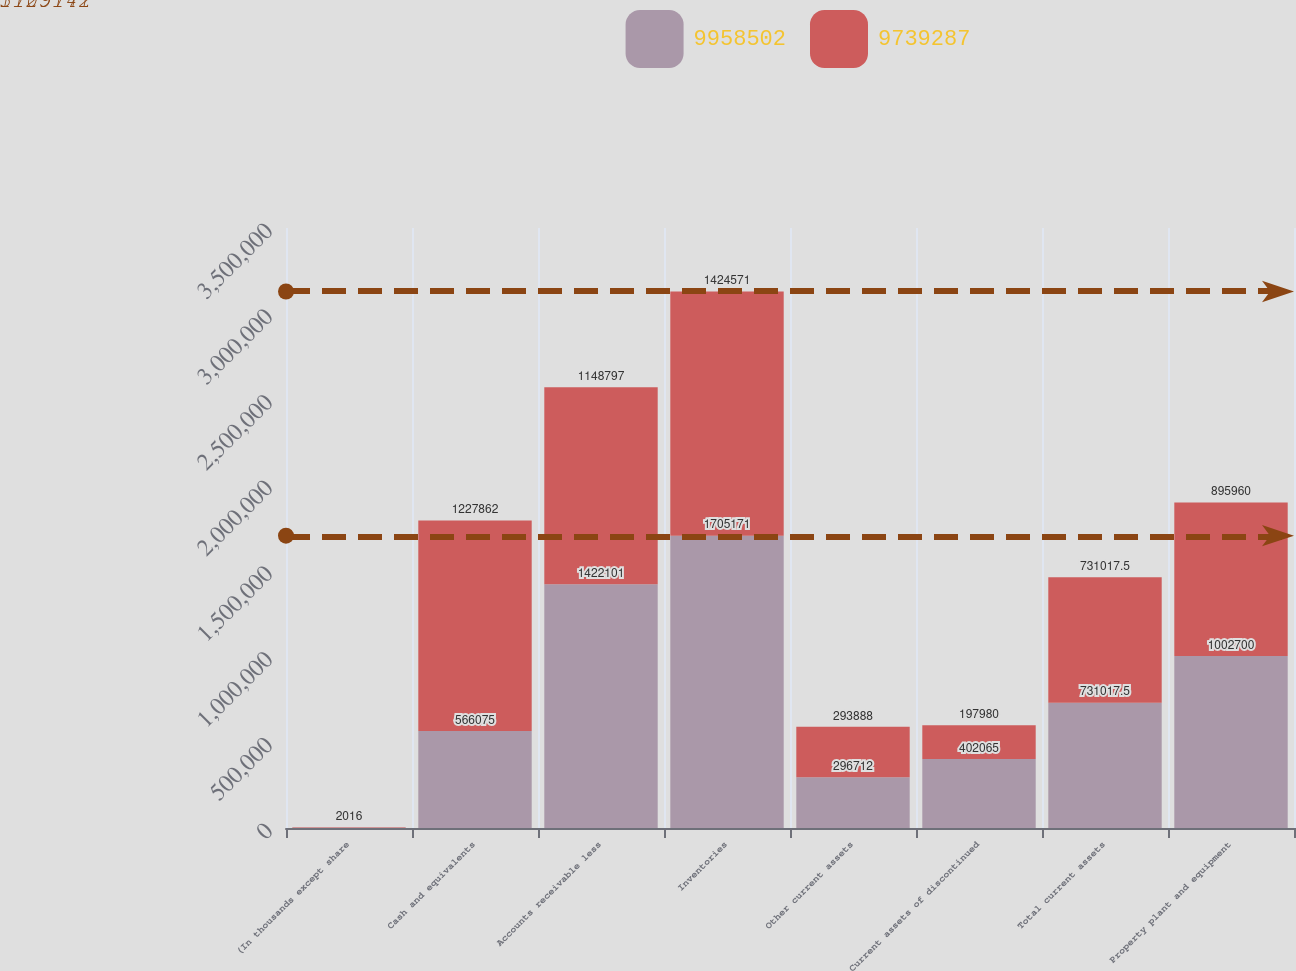Convert chart to OTSL. <chart><loc_0><loc_0><loc_500><loc_500><stacked_bar_chart><ecel><fcel>(In thousands except share<fcel>Cash and equivalents<fcel>Accounts receivable less<fcel>Inventories<fcel>Other current assets<fcel>Current assets of discontinued<fcel>Total current assets<fcel>Property plant and equipment<nl><fcel>9.9585e+06<fcel>2017<fcel>566075<fcel>1.4221e+06<fcel>1.70517e+06<fcel>296712<fcel>402065<fcel>731018<fcel>1.0027e+06<nl><fcel>9.73929e+06<fcel>2016<fcel>1.22786e+06<fcel>1.1488e+06<fcel>1.42457e+06<fcel>293888<fcel>197980<fcel>731018<fcel>895960<nl></chart> 